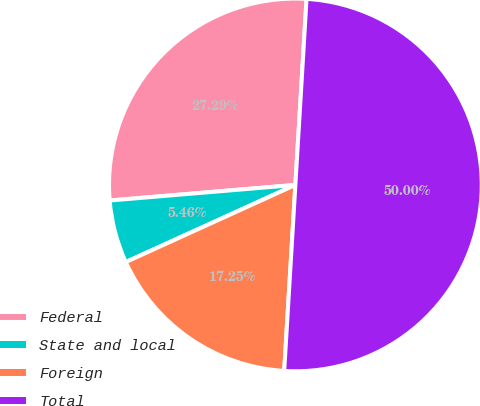<chart> <loc_0><loc_0><loc_500><loc_500><pie_chart><fcel>Federal<fcel>State and local<fcel>Foreign<fcel>Total<nl><fcel>27.29%<fcel>5.46%<fcel>17.25%<fcel>50.0%<nl></chart> 